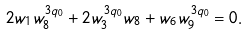<formula> <loc_0><loc_0><loc_500><loc_500>2 w _ { 1 } w _ { 8 } ^ { 3 q _ { 0 } } + 2 w _ { 3 } ^ { 3 q _ { 0 } } w _ { 8 } + w _ { 6 } w _ { 9 } ^ { 3 q _ { 0 } } = 0 .</formula> 